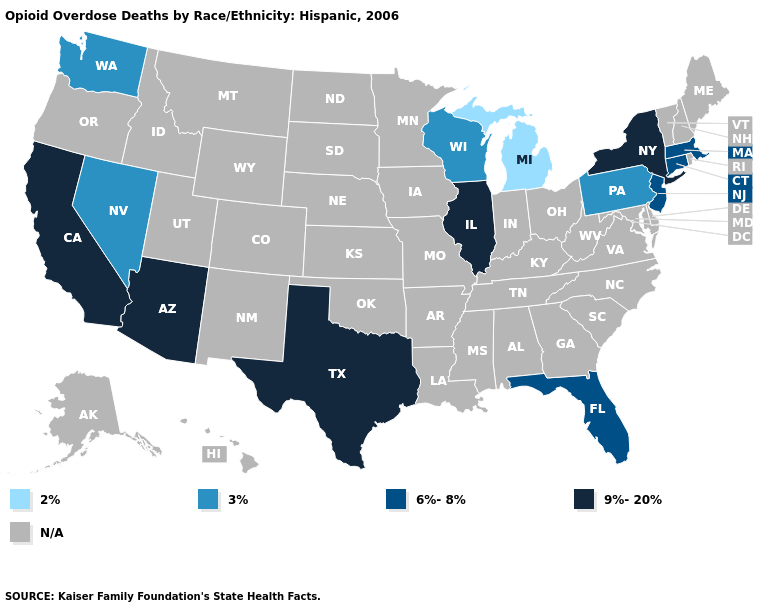Does Massachusetts have the lowest value in the USA?
Concise answer only. No. Name the states that have a value in the range N/A?
Quick response, please. Alabama, Alaska, Arkansas, Colorado, Delaware, Georgia, Hawaii, Idaho, Indiana, Iowa, Kansas, Kentucky, Louisiana, Maine, Maryland, Minnesota, Mississippi, Missouri, Montana, Nebraska, New Hampshire, New Mexico, North Carolina, North Dakota, Ohio, Oklahoma, Oregon, Rhode Island, South Carolina, South Dakota, Tennessee, Utah, Vermont, Virginia, West Virginia, Wyoming. Name the states that have a value in the range 2%?
Give a very brief answer. Michigan. Does Massachusetts have the lowest value in the Northeast?
Concise answer only. No. What is the value of Montana?
Concise answer only. N/A. Among the states that border Missouri , which have the highest value?
Keep it brief. Illinois. Does the first symbol in the legend represent the smallest category?
Keep it brief. Yes. What is the value of Pennsylvania?
Quick response, please. 3%. Does the map have missing data?
Concise answer only. Yes. Does the map have missing data?
Keep it brief. Yes. Name the states that have a value in the range N/A?
Give a very brief answer. Alabama, Alaska, Arkansas, Colorado, Delaware, Georgia, Hawaii, Idaho, Indiana, Iowa, Kansas, Kentucky, Louisiana, Maine, Maryland, Minnesota, Mississippi, Missouri, Montana, Nebraska, New Hampshire, New Mexico, North Carolina, North Dakota, Ohio, Oklahoma, Oregon, Rhode Island, South Carolina, South Dakota, Tennessee, Utah, Vermont, Virginia, West Virginia, Wyoming. 